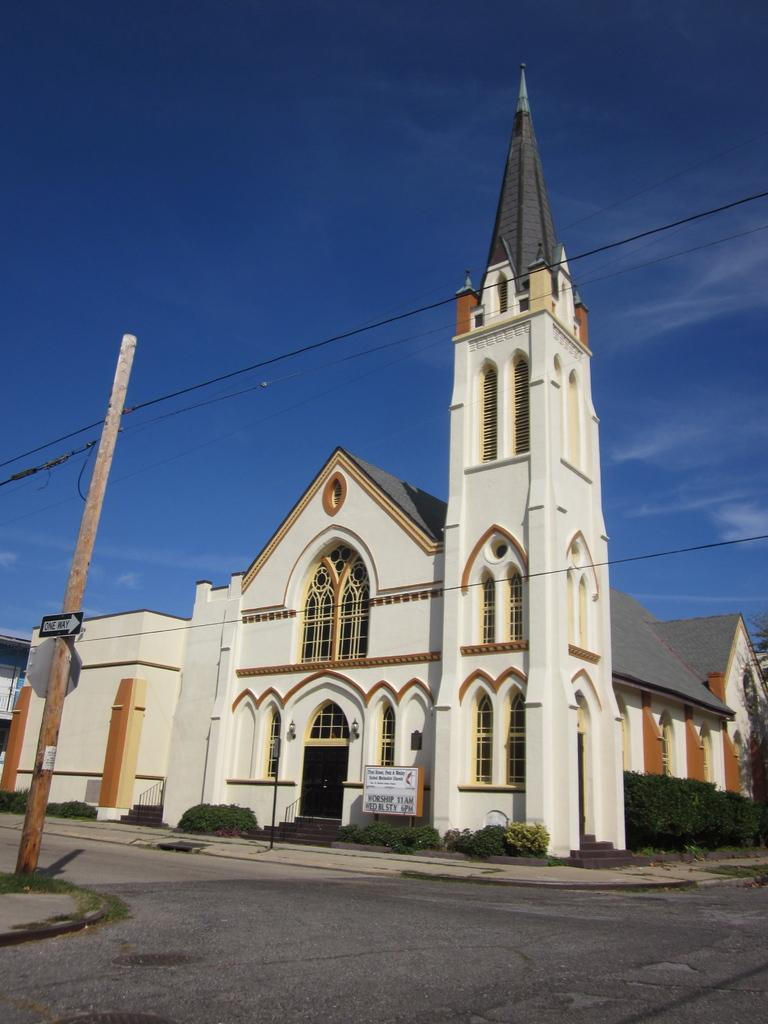What type of structure is present in the picture? There is a building in the picture. What features can be seen on the building? The building has a door and windows. What else is present in the picture besides the building? There are poles and trees in the picture. What is the condition of the sky in the picture? The sky is clear in the picture. Can you tell me how many brains are visible in the picture? There are no brains present in the picture; it features a building with a door and windows, poles, trees, and a clear sky. What type of wilderness can be seen in the background of the picture? There is no wilderness visible in the picture; it features a building, poles, trees, and a clear sky. 